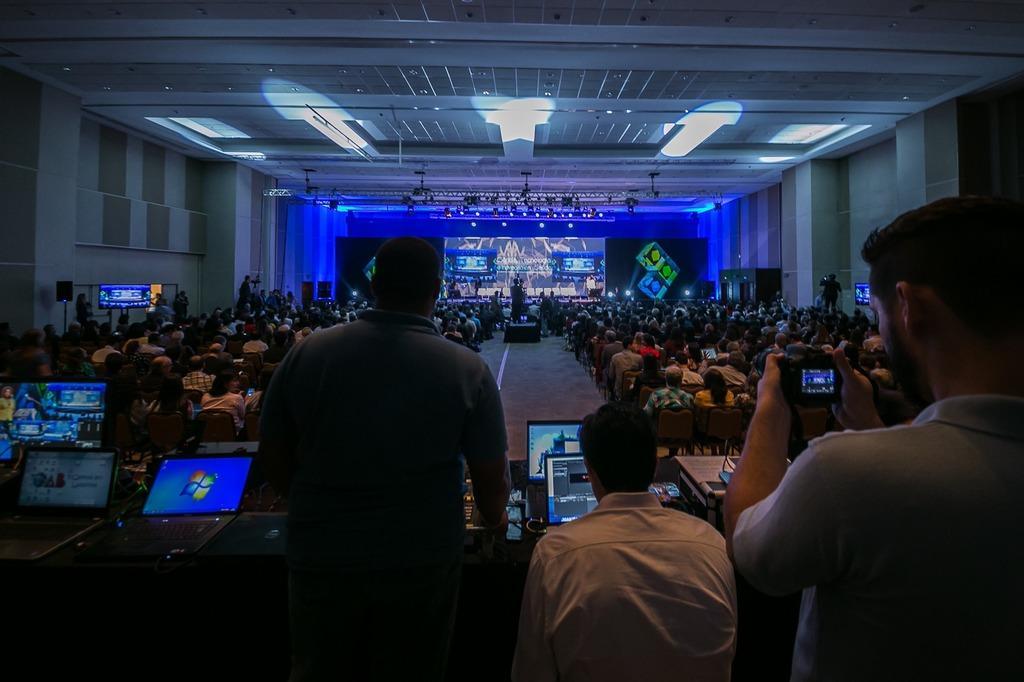How would you summarize this image in a sentence or two? In this image there are three persons in the bottom of this image and there are some laptops kept on a table and there is a screen in middle of this image and there are some persons sitting on the chairs as we can see in middle of this image. There is a wall in the background , There are some lights arranged on the top of this image. 